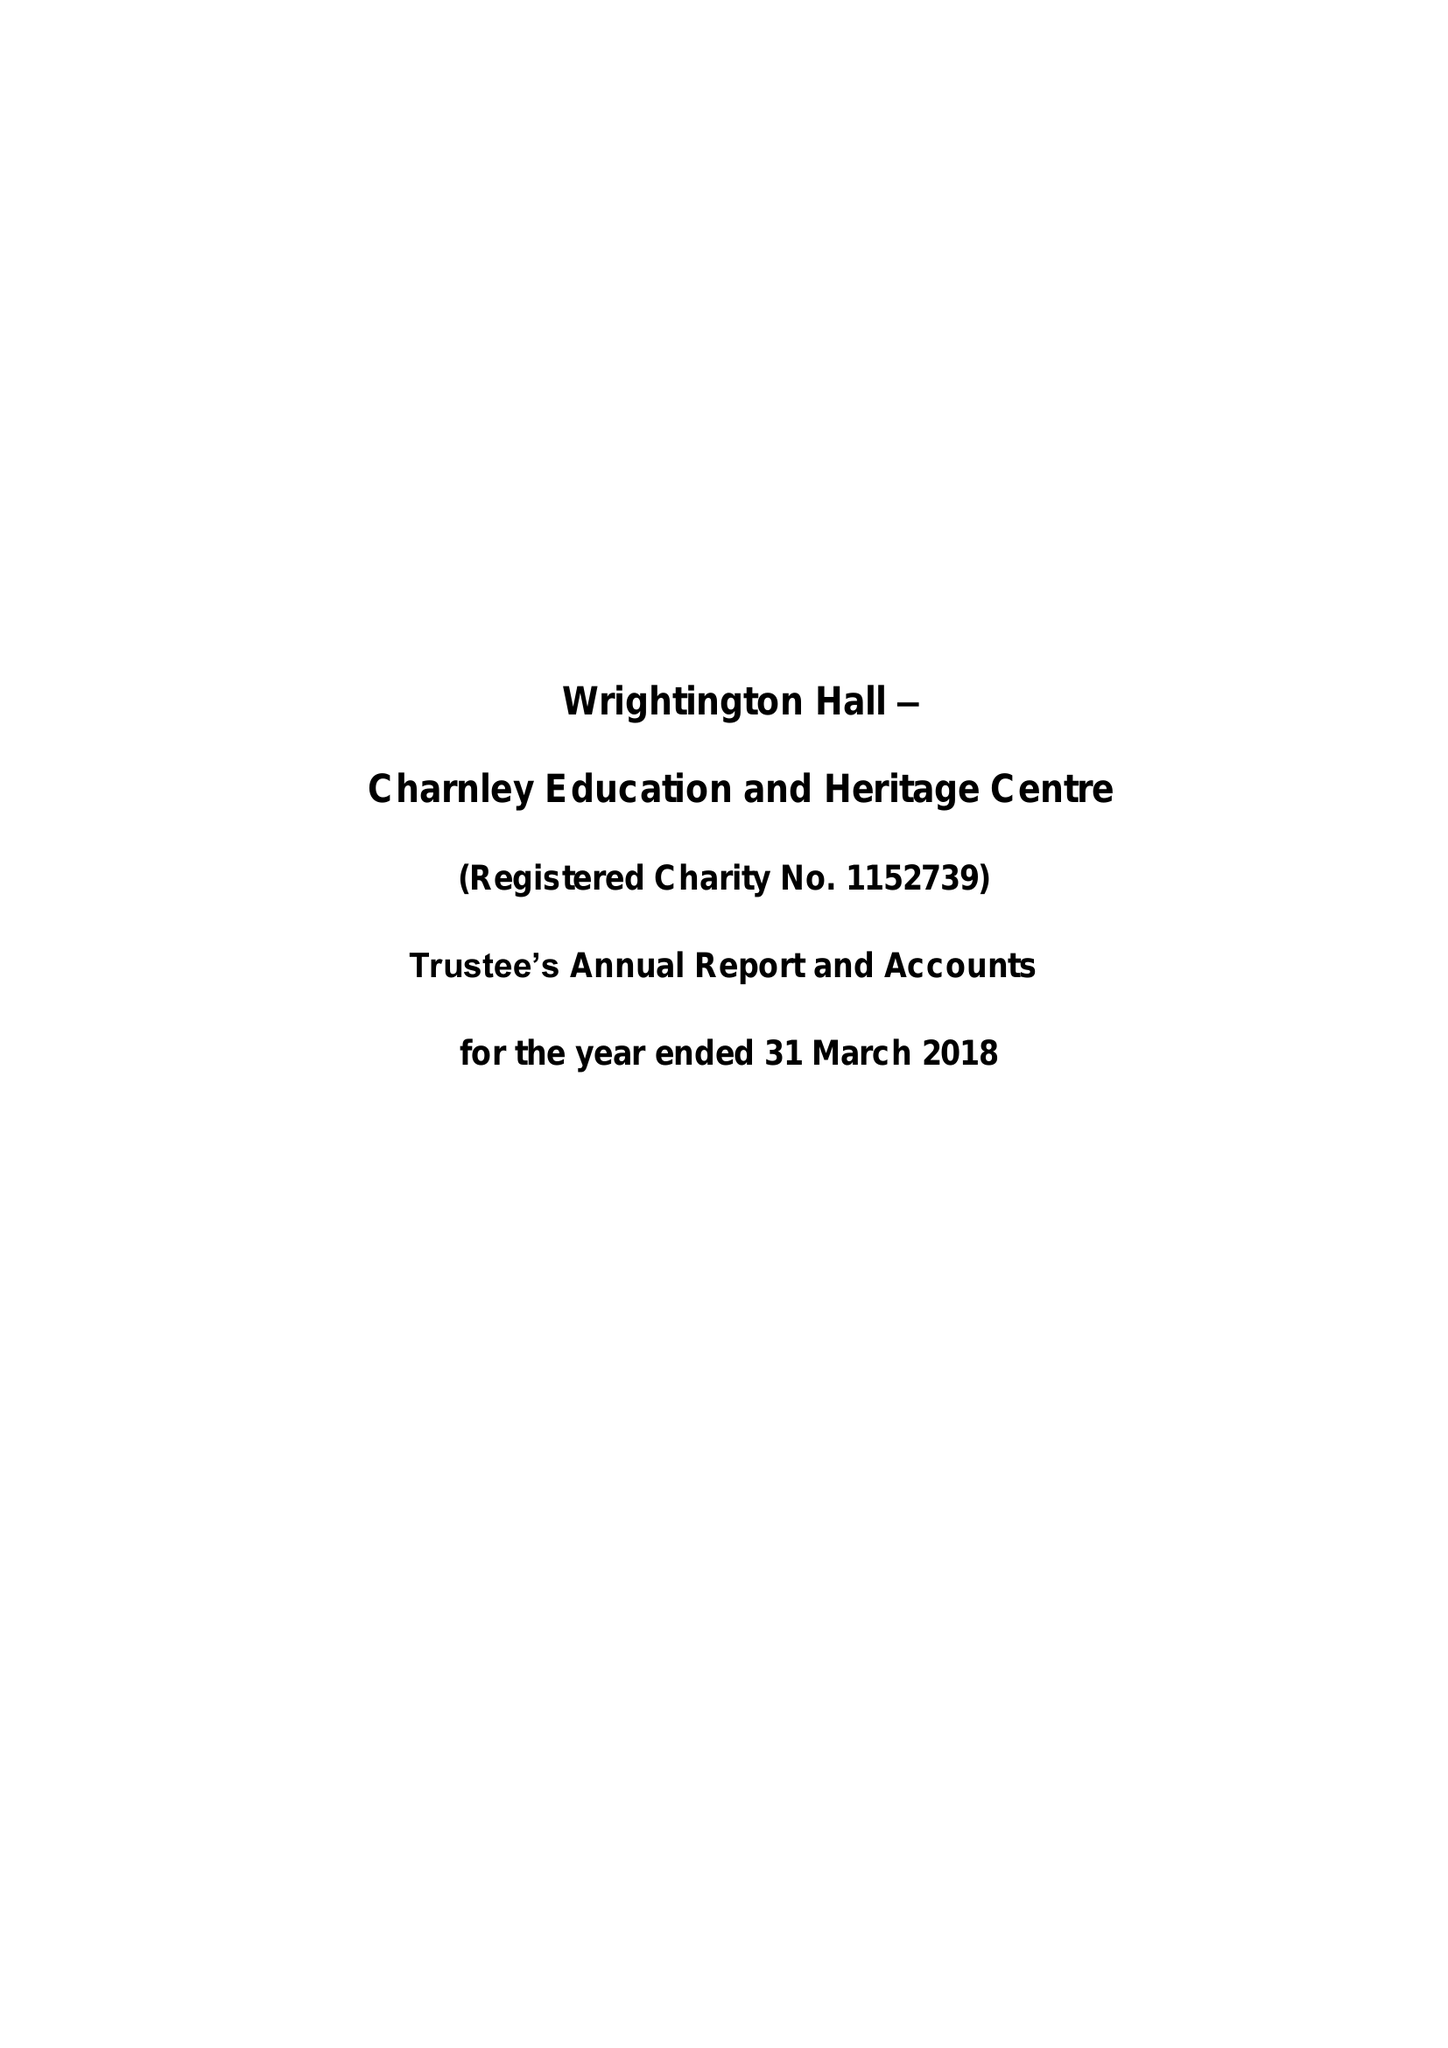What is the value for the address__postcode?
Answer the question using a single word or phrase. PR7 7NA 